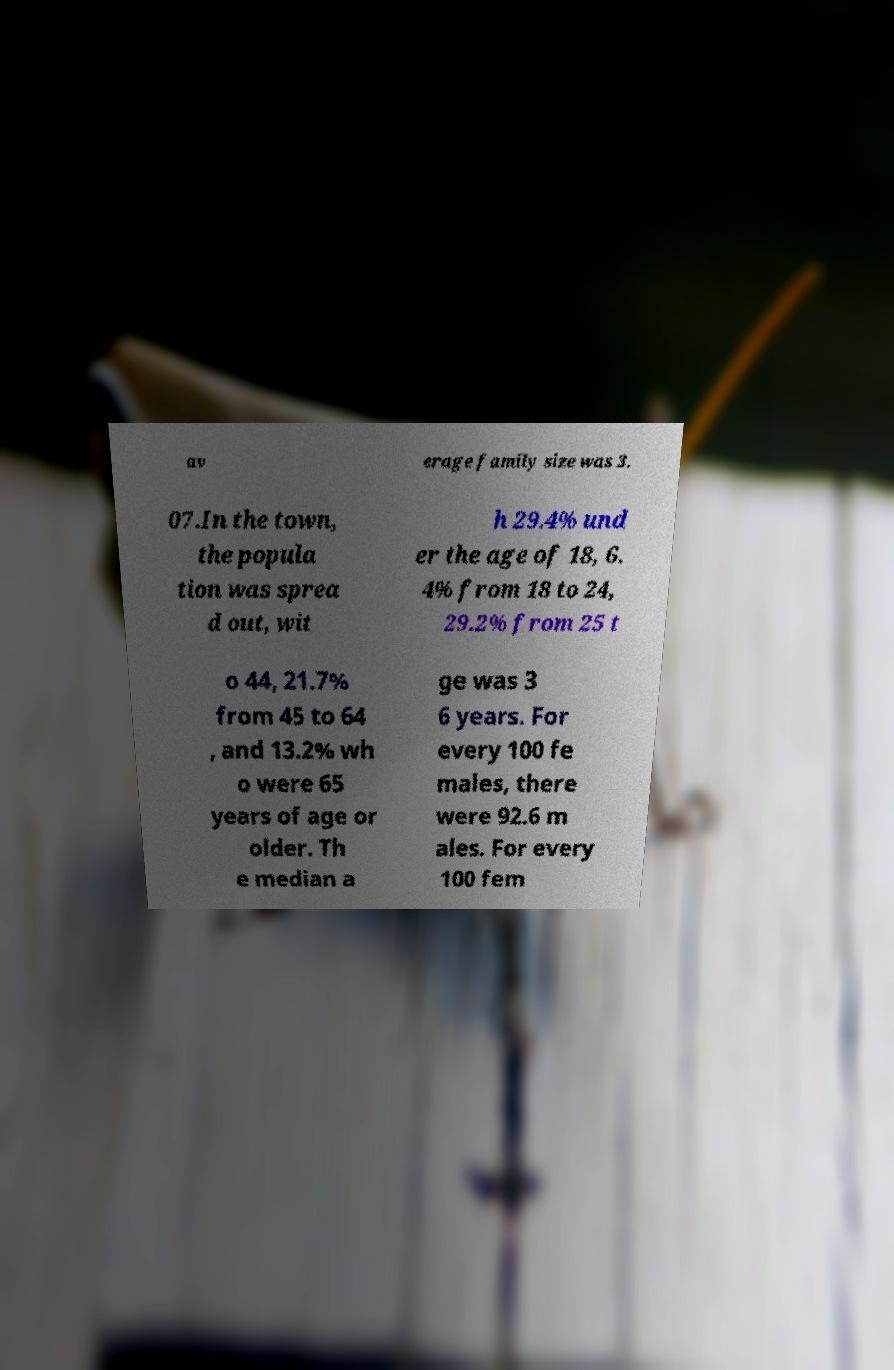Could you extract and type out the text from this image? av erage family size was 3. 07.In the town, the popula tion was sprea d out, wit h 29.4% und er the age of 18, 6. 4% from 18 to 24, 29.2% from 25 t o 44, 21.7% from 45 to 64 , and 13.2% wh o were 65 years of age or older. Th e median a ge was 3 6 years. For every 100 fe males, there were 92.6 m ales. For every 100 fem 